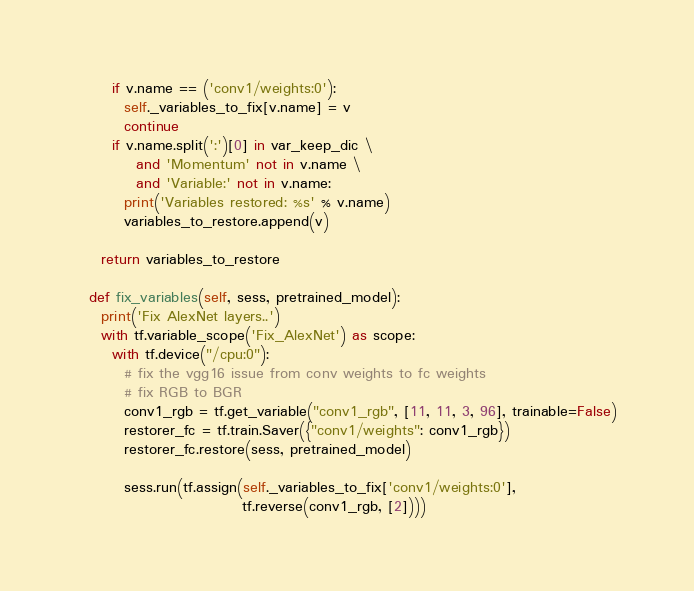Convert code to text. <code><loc_0><loc_0><loc_500><loc_500><_Python_>      if v.name == ('conv1/weights:0'):
        self._variables_to_fix[v.name] = v
        continue
      if v.name.split(':')[0] in var_keep_dic \
          and 'Momentum' not in v.name \
          and 'Variable:' not in v.name:
        print('Variables restored: %s' % v.name)
        variables_to_restore.append(v)

    return variables_to_restore

  def fix_variables(self, sess, pretrained_model):
    print('Fix AlexNet layers..')
    with tf.variable_scope('Fix_AlexNet') as scope:
      with tf.device("/cpu:0"):
        # fix the vgg16 issue from conv weights to fc weights
        # fix RGB to BGR
        conv1_rgb = tf.get_variable("conv1_rgb", [11, 11, 3, 96], trainable=False)
        restorer_fc = tf.train.Saver({"conv1/weights": conv1_rgb})
        restorer_fc.restore(sess, pretrained_model)

        sess.run(tf.assign(self._variables_to_fix['conv1/weights:0'], 
                            tf.reverse(conv1_rgb, [2])))
</code> 